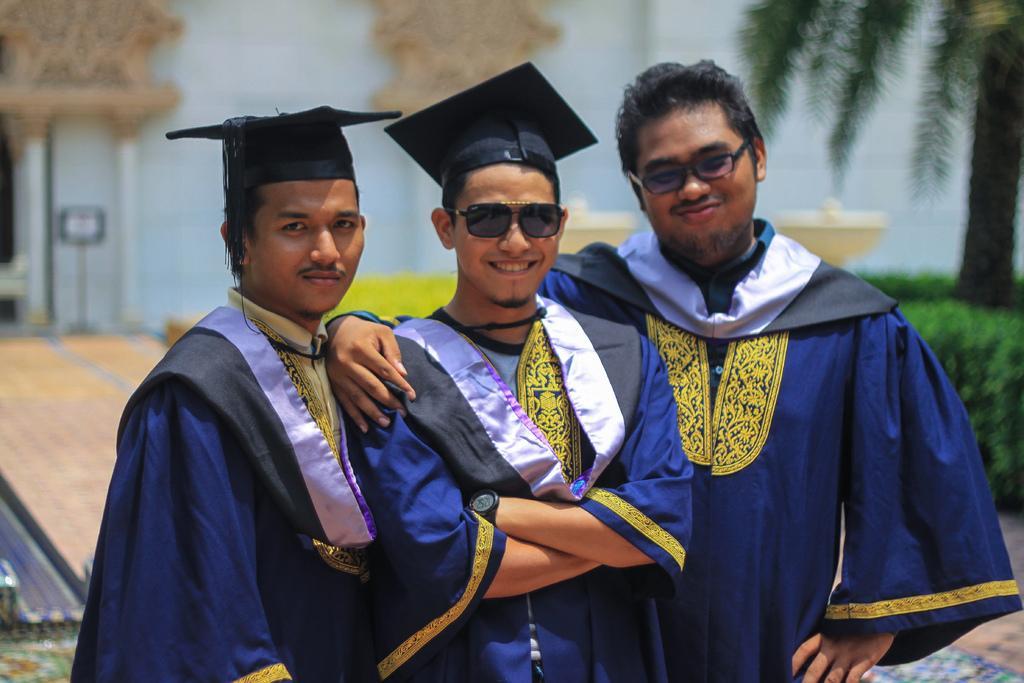How would you summarize this image in a sentence or two? Background portion of the picture is blur and we can see a tree, pillars and a board. In this picture we can see three men standing and among them two wore spectacles and two wore hats. All are smiling. 